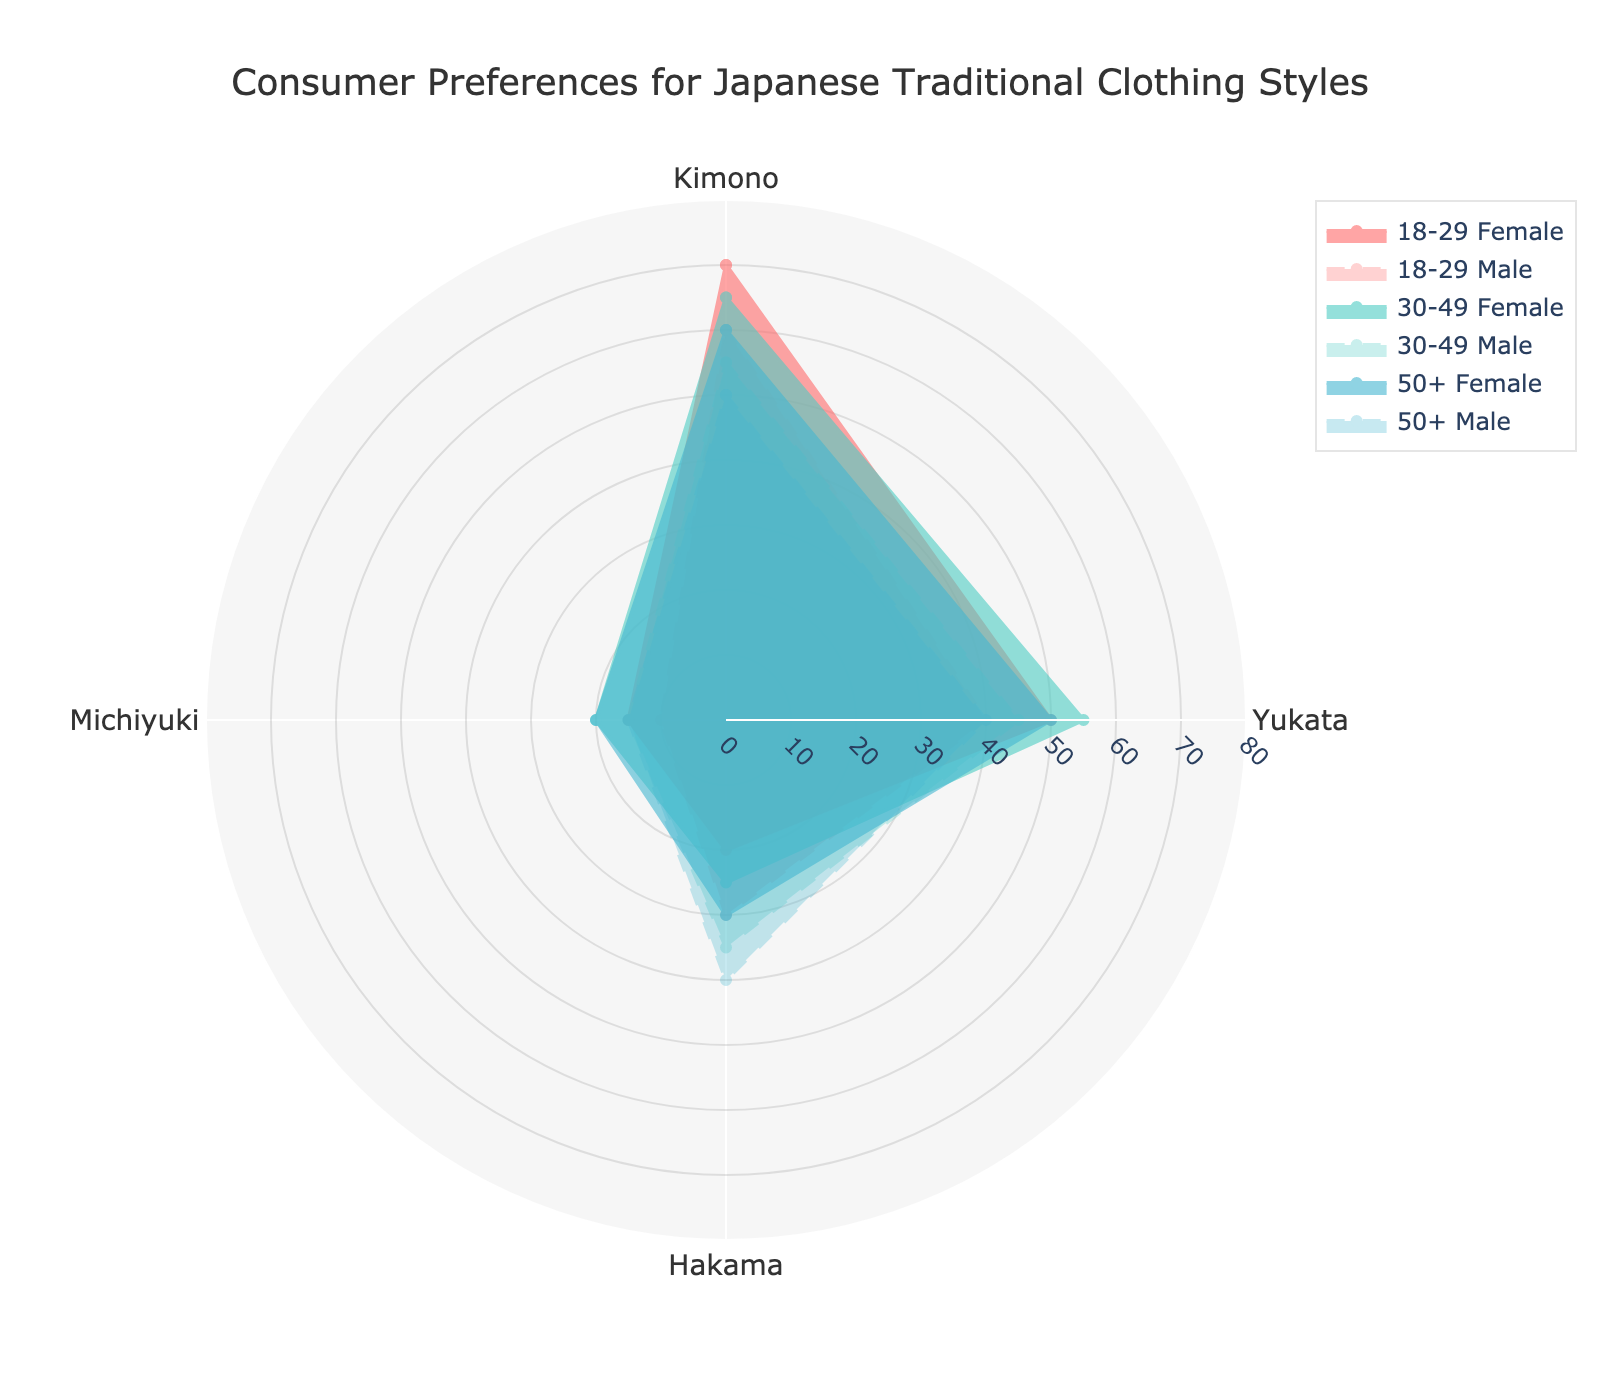Which age group has the highest preference for Kimono among females? Look at the radar chart and find the point for 'Kimono' for each female group. The highest points correspond to the age group with the highest preference.
Answer: 18-29 Which age group and gender combination has the highest preference for Hakama? Identify the values for 'Hakama' across all age group and gender combinations in the radar chart, and determine which has the highest value.
Answer: 50+ Male Do males or females have a higher preference for Yukata in the 30-49 age group? Compare the values for 'Yukata' between males and females in the 30-49 age group.
Answer: Female What is the overall trend in preferences for Michiyuki across all age groups for males? Examine all the values for 'Michiyuki' for males in different age groups and note the trend.
Answer: Increasing How does the preference for Kimono change from the 18-29 to the 50+ age group for females? Compare the values for 'Kimono' in the 18-29 and 50+ age groups for females to understand how the preference changes as age increases.
Answer: Decreases Which clothing style has the most consistent preference across all age groups and genders? Observe the radar chart to determine which clothing style’s values show the least variation across age groups and genders.
Answer: Yukata Is there an age group where males and females have similar preferences for any clothing style? Check the values for each clothing style across age groups to find instances where the preferences of males and females are similar.
Answer: 50+ (Michiyuki) Which age group has the most significant difference in preferences for Hakama between males and females? Compare the difference in values for 'Hakama' between males and females in each age group, determining which has the largest gap.
Answer: 18-29 What is the least preferred clothing style for females in the 30-49 age group? Look at the radar chart and find the lowest point among the clothing styles for females in the 30-49 age group.
Answer: Michiyuki How many age groups show a higher preference for Kimono over Yukata among males? Compare the values for 'Kimono' and 'Yukata' among males across all age groups and count how many groups have a higher Kimono preference.
Answer: 1 